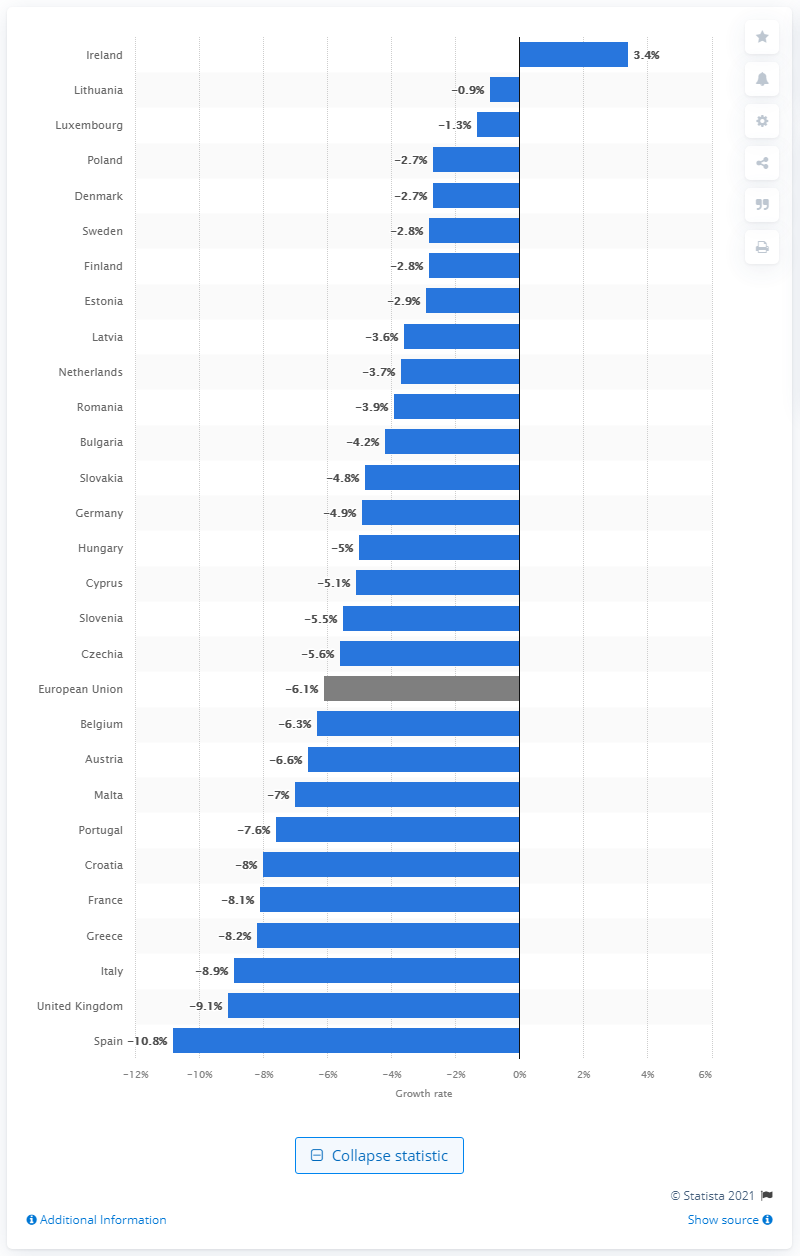Draw attention to some important aspects in this diagram. In 2020, the Gross Domestic Product (GDP) of Ireland grew by 3.4%. 